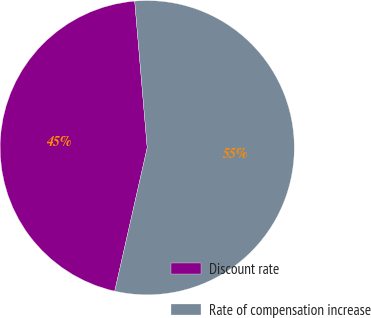<chart> <loc_0><loc_0><loc_500><loc_500><pie_chart><fcel>Discount rate<fcel>Rate of compensation increase<nl><fcel>45.1%<fcel>54.9%<nl></chart> 